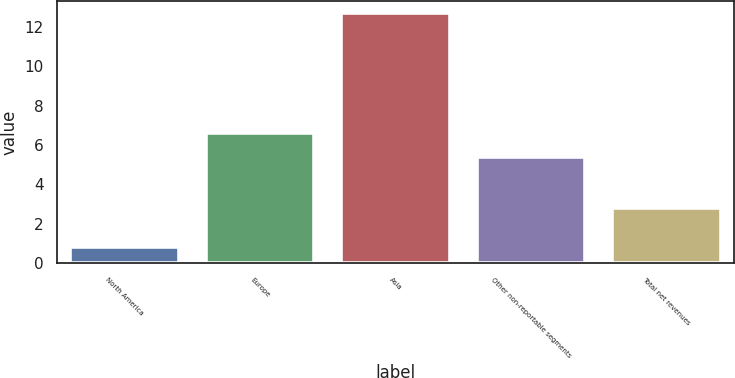<chart> <loc_0><loc_0><loc_500><loc_500><bar_chart><fcel>North America<fcel>Europe<fcel>Asia<fcel>Other non-reportable segments<fcel>Total net revenues<nl><fcel>0.8<fcel>6.59<fcel>12.7<fcel>5.4<fcel>2.8<nl></chart> 